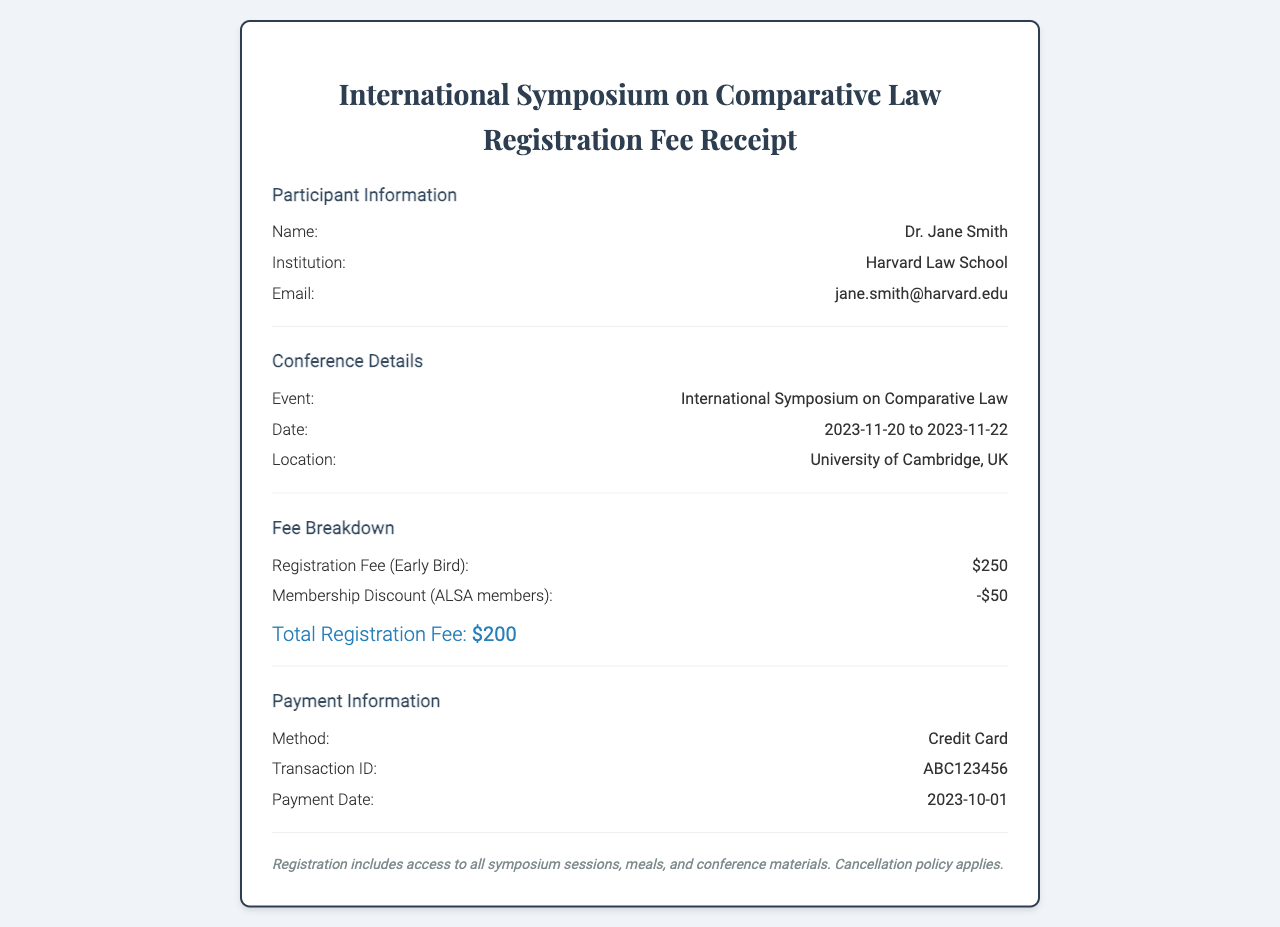What is the participant's name? The participant's name is stated in the "Participant Information" section of the document.
Answer: Dr. Jane Smith What is the registration fee after the membership discount? The total registration fee after applying the membership discount is calculated in the "Fee Breakdown" section.
Answer: $200 What date does the symposium take place? The date of the symposium is mentioned in the "Conference Details" section of the document.
Answer: 2023-11-20 to 2023-11-22 What institution is Dr. Jane Smith affiliated with? The institution is listed under the "Participant Information" section.
Answer: Harvard Law School What is the payment method used for the registration? The payment method is specified in the "Payment Information" section of the document.
Answer: Credit Card How much is the early bird registration fee? This amount is detailed in the "Fee Breakdown" section under registration fees.
Answer: $250 What does the registration fee include? The inclusions are noted at the bottom of the receipt in the "notes" section.
Answer: Access to all symposium sessions, meals, and conference materials What is the transaction ID for the payment? The transaction ID is provided in the "Payment Information" section.
Answer: ABC123456 Which organization offered the membership discount? The organization is referenced in the "Fee Breakdown" section regarding the discount.
Answer: ALSA 